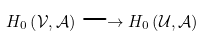<formula> <loc_0><loc_0><loc_500><loc_500>H _ { 0 } \left ( \mathcal { V } , \mathcal { A } \right ) \longrightarrow H _ { 0 } \left ( \mathcal { U } , \mathcal { A } \right )</formula> 